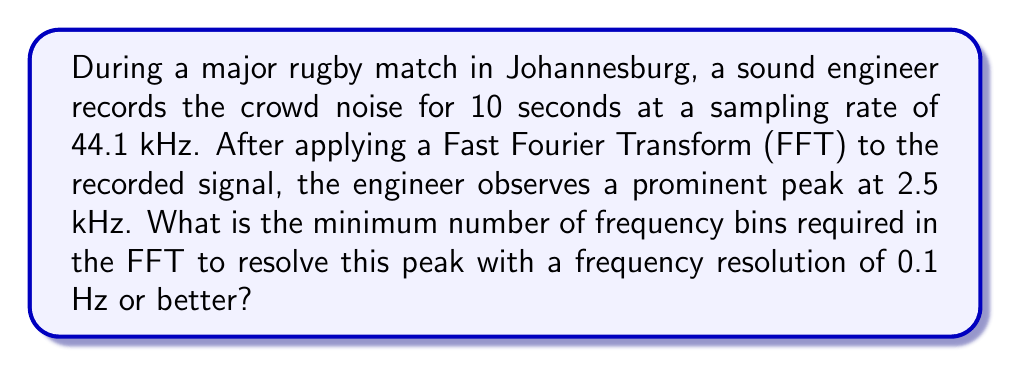Show me your answer to this math problem. To solve this problem, we need to follow these steps:

1. Calculate the total number of samples in the recording:
   $N = \text{sampling rate} \times \text{duration}$
   $N = 44100 \text{ Hz} \times 10 \text{ s} = 441000 \text{ samples}$

2. Determine the frequency resolution of the FFT:
   $\Delta f = \frac{\text{sampling rate}}{N} = \frac{44100 \text{ Hz}}{441000} = 0.1 \text{ Hz}$

3. The number of frequency bins in an FFT is equal to $N/2 + 1$, where $N$ is the number of time-domain samples. So, the initial number of frequency bins is:
   $\text{bins} = 441000/2 + 1 = 220501$

4. This gives us exactly the desired frequency resolution of 0.1 Hz. To ensure we have "0.1 Hz or better" resolution, we need at least this many bins.

Therefore, the minimum number of frequency bins required is 220501.
Answer: 220501 bins 